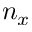Convert formula to latex. <formula><loc_0><loc_0><loc_500><loc_500>n _ { x }</formula> 